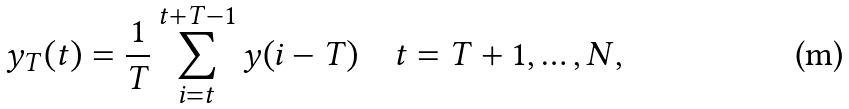<formula> <loc_0><loc_0><loc_500><loc_500>y _ { T } ( t ) = \frac { 1 } { T } \sum _ { i = t } ^ { t + T - 1 } y ( i - T ) \quad t = T + 1 , \dots , N ,</formula> 